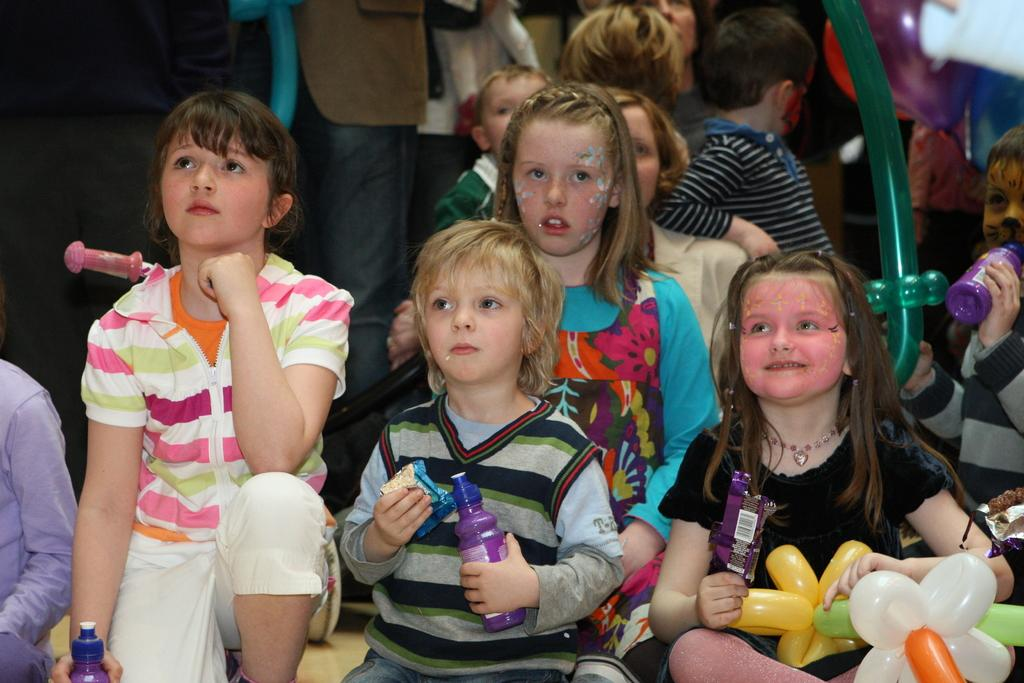Who or what can be seen in the image? There are children in the image. What are some of the children holding? Some of the children are holding bottles. Can you describe the expressions on the children's faces? There are smiles visible on some of the children's faces. What type of writer can be seen in the image? There is no writer present in the image; it features children holding bottles and smiling. 